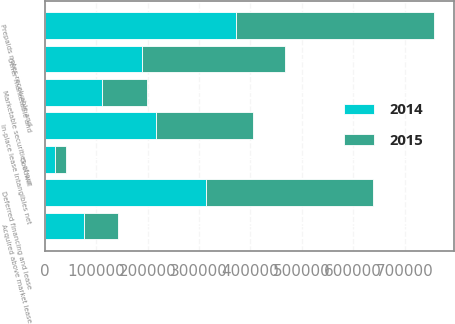<chart> <loc_0><loc_0><loc_500><loc_500><stacked_bar_chart><ecel><fcel>Deferred financing and lease<fcel>In-place lease intangibles net<fcel>Acquired above market lease<fcel>Marketable securities of our<fcel>Goodwill<fcel>Other marketable and<fcel>Prepaids notes receivable and<nl><fcel>2015<fcel>325720<fcel>188219<fcel>67363<fcel>87257<fcel>20098<fcel>278026<fcel>385576<nl><fcel>2014<fcel>312569<fcel>216330<fcel>75366<fcel>111844<fcel>20098<fcel>188219<fcel>372317<nl></chart> 